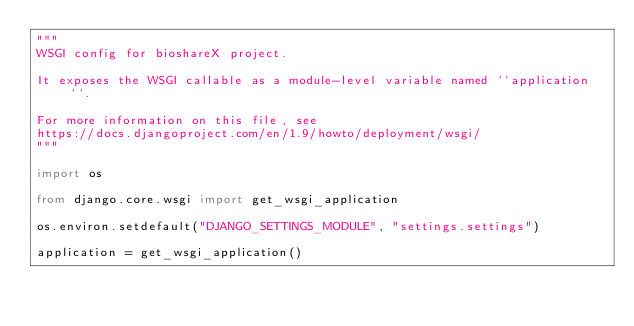<code> <loc_0><loc_0><loc_500><loc_500><_Python_>"""
WSGI config for bioshareX project.

It exposes the WSGI callable as a module-level variable named ``application``.

For more information on this file, see
https://docs.djangoproject.com/en/1.9/howto/deployment/wsgi/
"""

import os

from django.core.wsgi import get_wsgi_application

os.environ.setdefault("DJANGO_SETTINGS_MODULE", "settings.settings")

application = get_wsgi_application()
</code> 